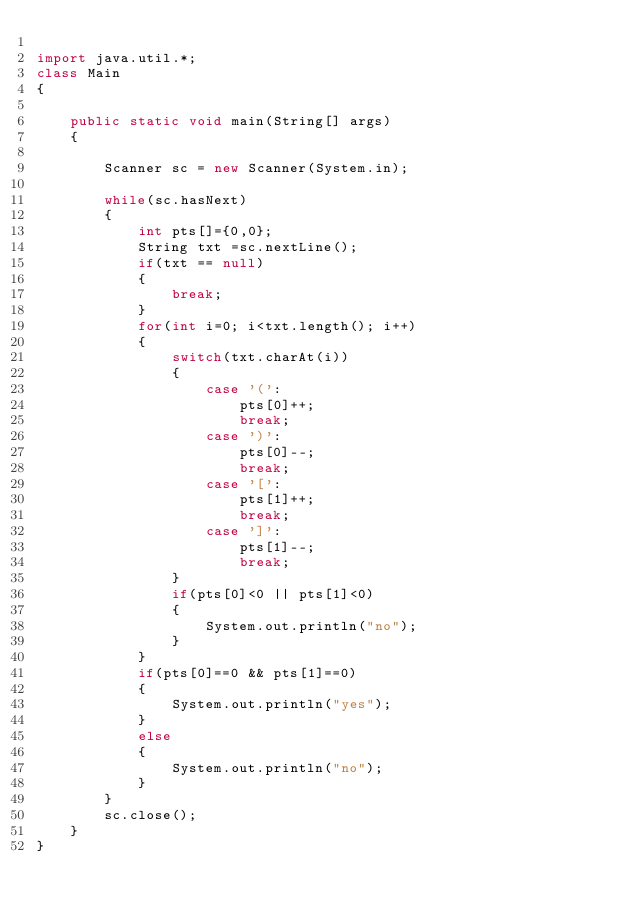Convert code to text. <code><loc_0><loc_0><loc_500><loc_500><_Java_>
import java.util.*;
class Main
{

    public static void main(String[] args)
    {

        Scanner sc = new Scanner(System.in);

        while(sc.hasNext)
        {
            int pts[]={0,0};
            String txt =sc.nextLine();
            if(txt == null)
            {
                break;
            }
            for(int i=0; i<txt.length(); i++)
            {
                switch(txt.charAt(i))
                {
                    case '(':
                        pts[0]++;
                        break;
                    case ')':
                        pts[0]--;
                        break;
                    case '[':
                        pts[1]++;
                        break;
                    case ']':
                        pts[1]--;
                        break;
                }
                if(pts[0]<0 || pts[1]<0)
                {
                    System.out.println("no");
                }
            }
            if(pts[0]==0 && pts[1]==0)
            {
                System.out.println("yes");
            }
            else
            {
                System.out.println("no");
            }
        }
        sc.close();
    }
}</code> 